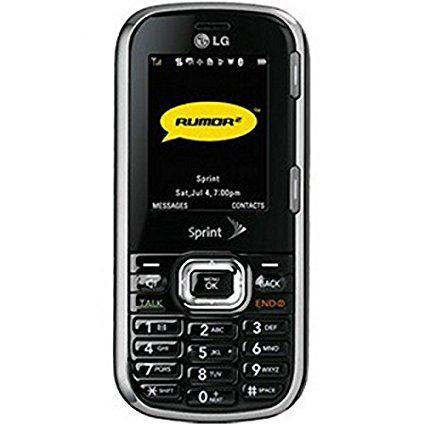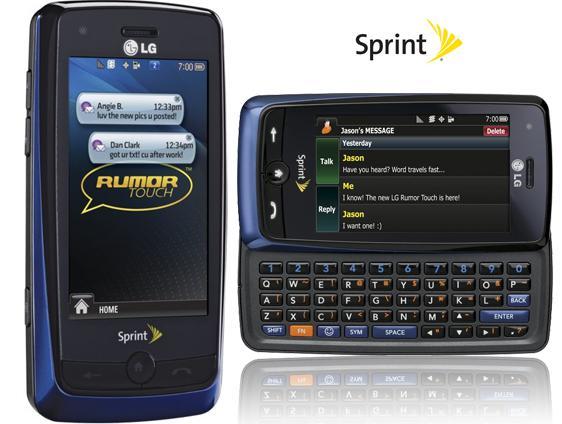The first image is the image on the left, the second image is the image on the right. Considering the images on both sides, is "All phones are shown upright, and none of them have physical keyboards." valid? Answer yes or no. No. The first image is the image on the left, the second image is the image on the right. Examine the images to the left and right. Is the description "All devices are rectangular and displayed vertically, and at least one device has geometric shapes of different colors filling its screen." accurate? Answer yes or no. No. 